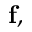Convert formula to latex. <formula><loc_0><loc_0><loc_500><loc_500>f ,</formula> 